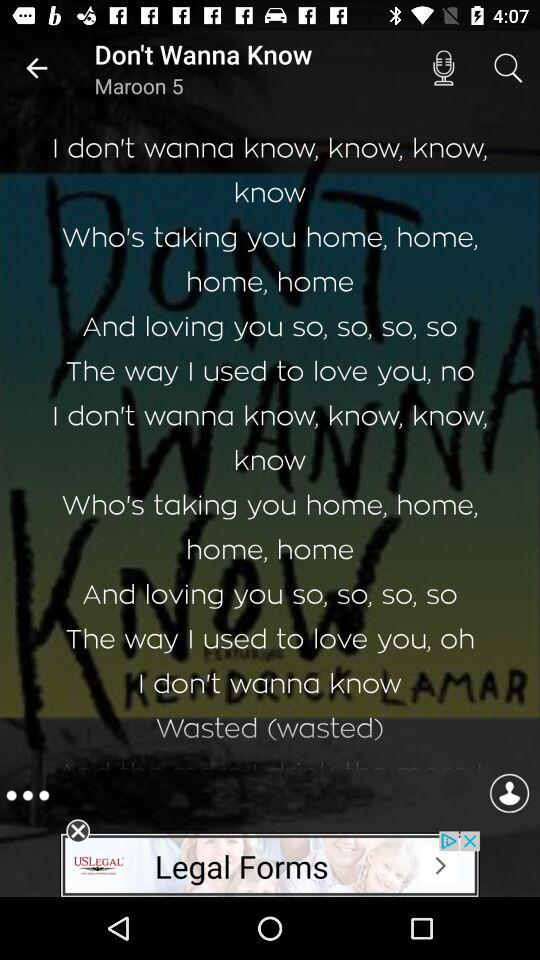How many likes does the song have?
When the provided information is insufficient, respond with <no answer>. <no answer> 